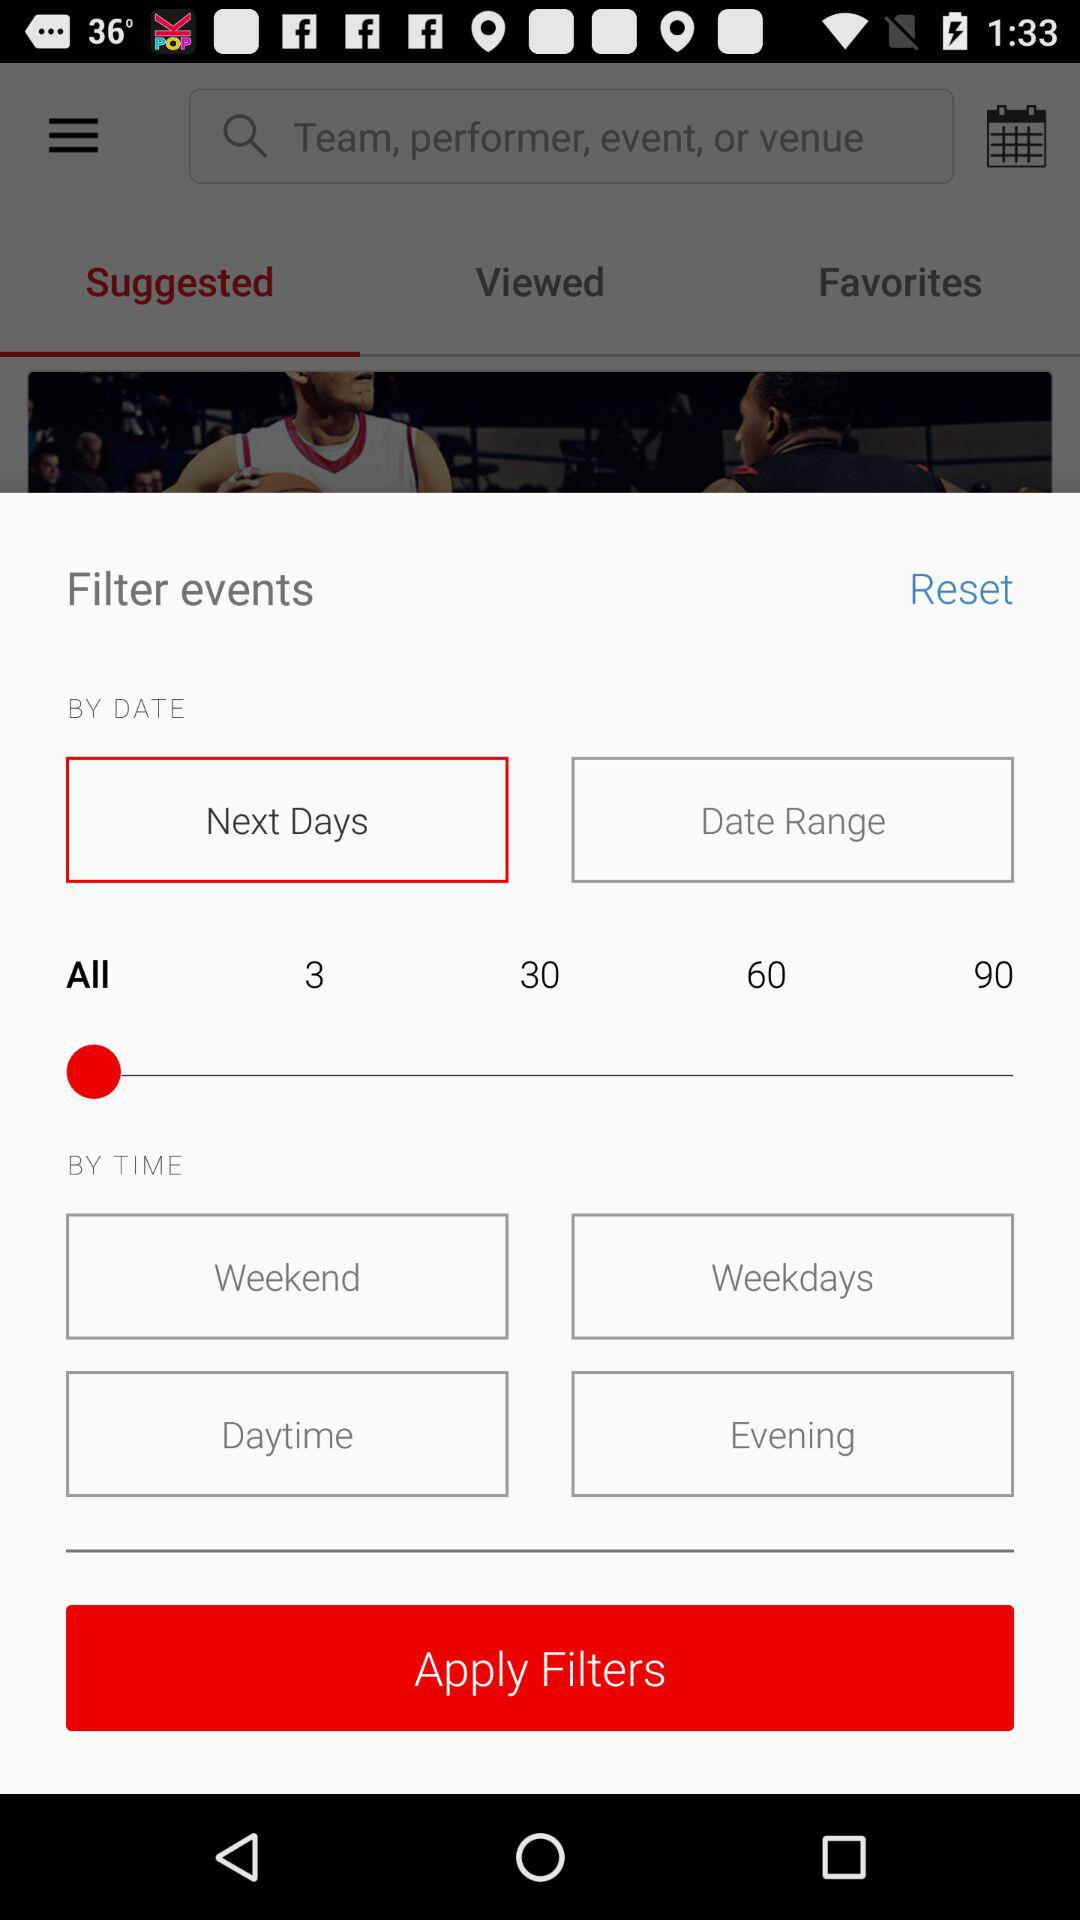What's the opted Day Range?
When the provided information is insufficient, respond with <no answer>. <no answer> 